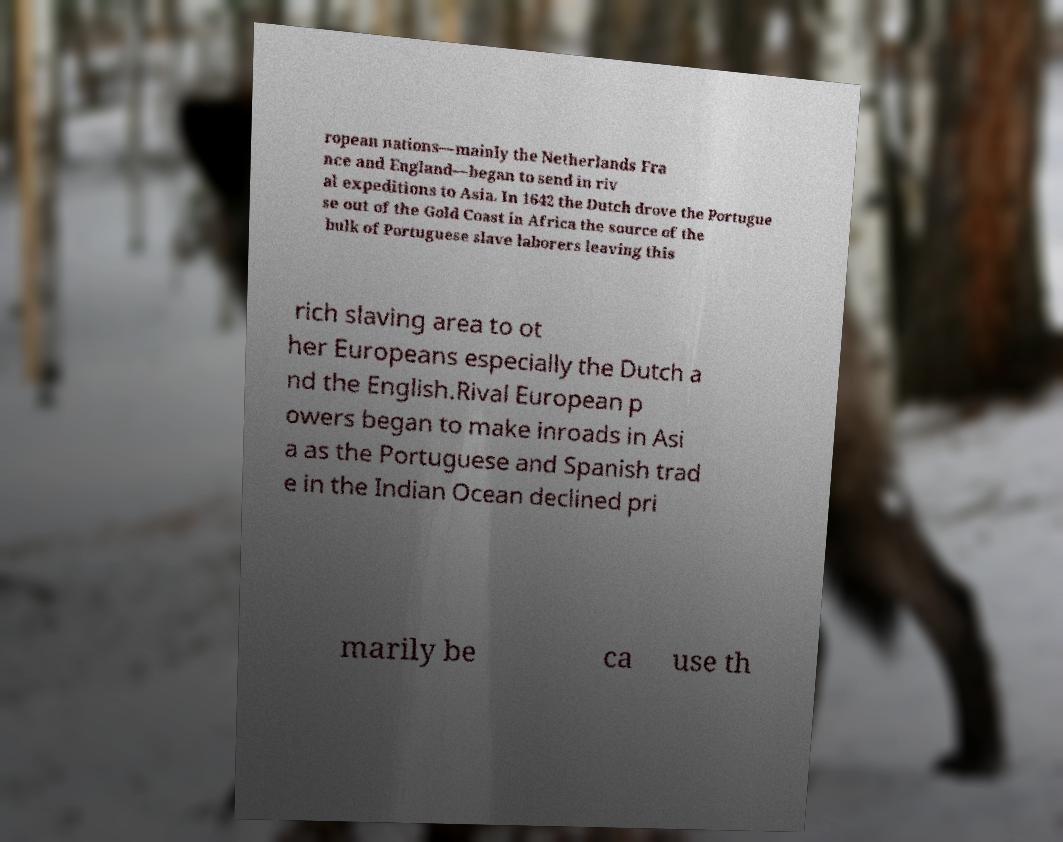Can you read and provide the text displayed in the image?This photo seems to have some interesting text. Can you extract and type it out for me? ropean nations—mainly the Netherlands Fra nce and England—began to send in riv al expeditions to Asia. In 1642 the Dutch drove the Portugue se out of the Gold Coast in Africa the source of the bulk of Portuguese slave laborers leaving this rich slaving area to ot her Europeans especially the Dutch a nd the English.Rival European p owers began to make inroads in Asi a as the Portuguese and Spanish trad e in the Indian Ocean declined pri marily be ca use th 